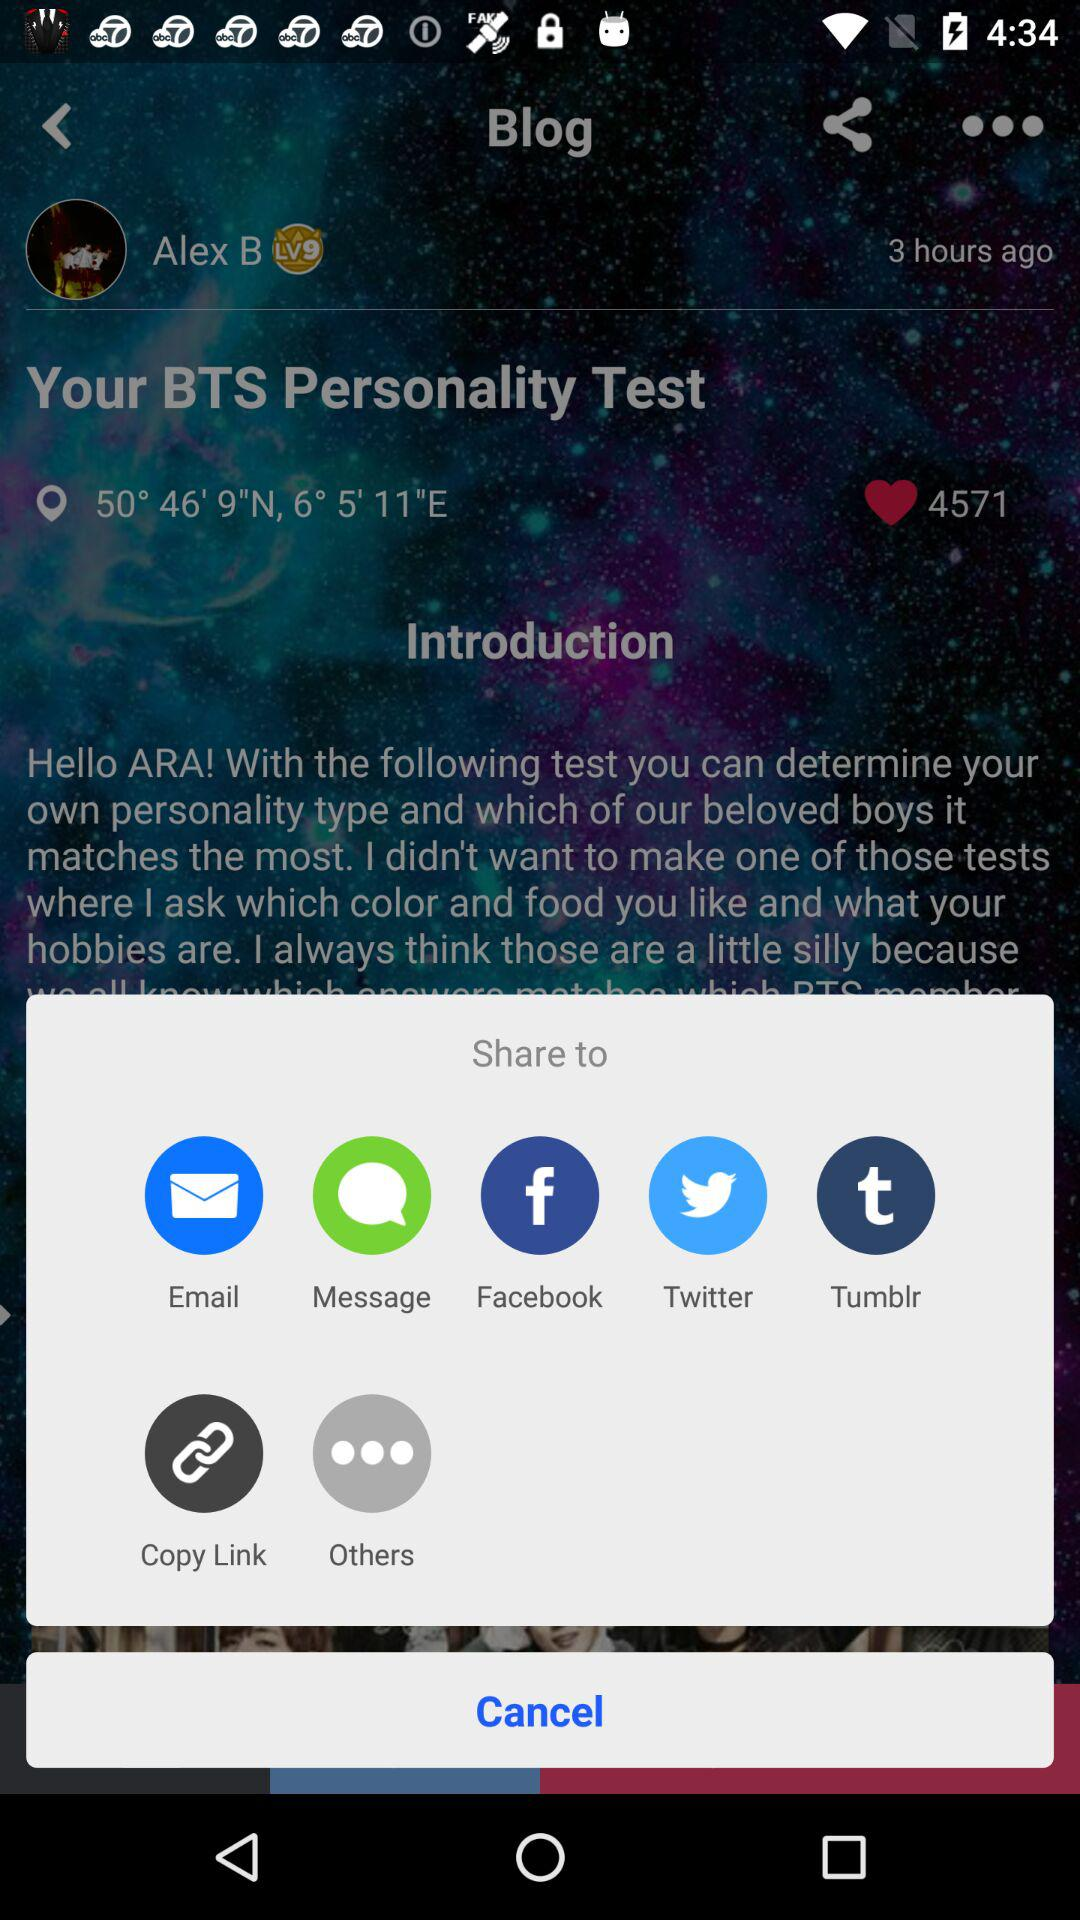Through which application can we send? You can send through "Email", "Message", "Facebook", "Twitter", and "Tumblr". 